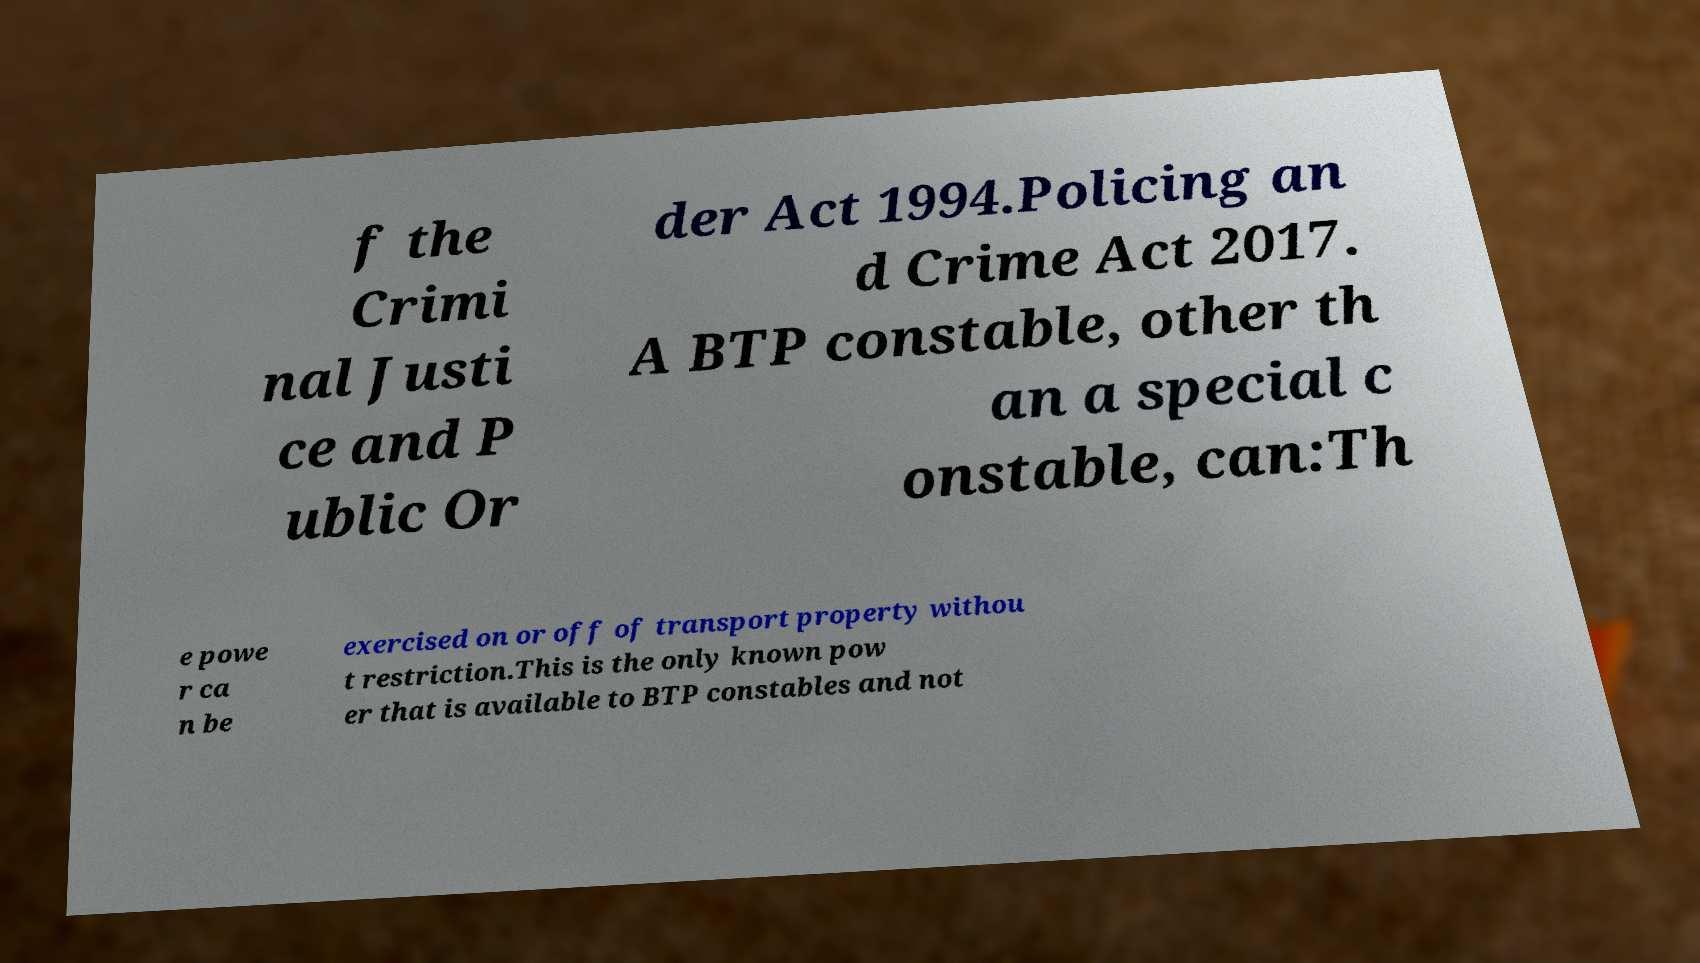Could you extract and type out the text from this image? f the Crimi nal Justi ce and P ublic Or der Act 1994.Policing an d Crime Act 2017. A BTP constable, other th an a special c onstable, can:Th e powe r ca n be exercised on or off of transport property withou t restriction.This is the only known pow er that is available to BTP constables and not 